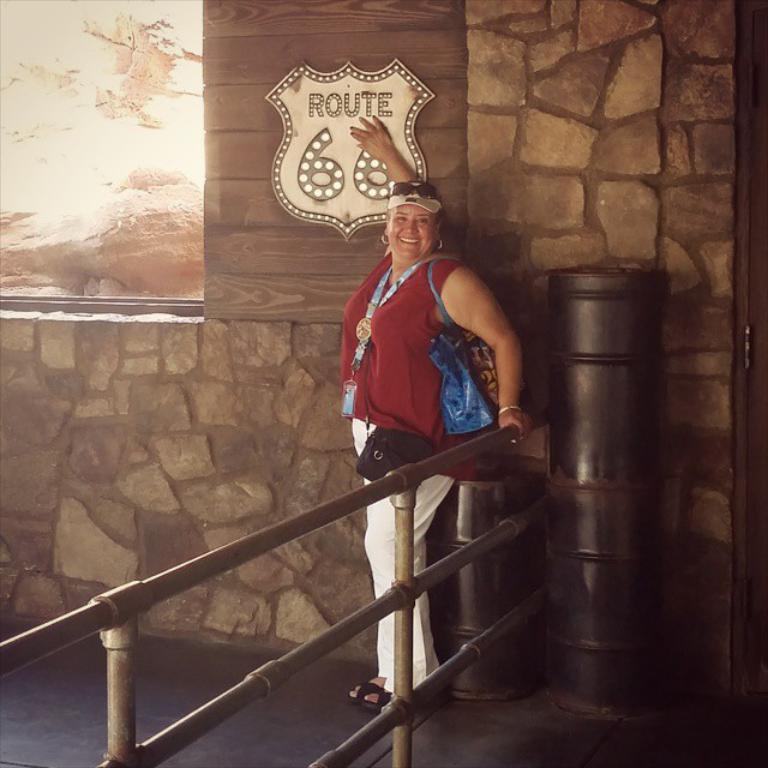What is the main subject of the image? There is a woman standing in the image. What color is the object in the image? There is a black color object in the image. What can be seen in the background of the image? There is a wall in the image. What type of wilderness can be seen in the image? There is no wilderness present in the image; it features a woman standing and a black object in front of a wall. How many pieces of quartz are visible in the image? There is no quartz present in the image. 